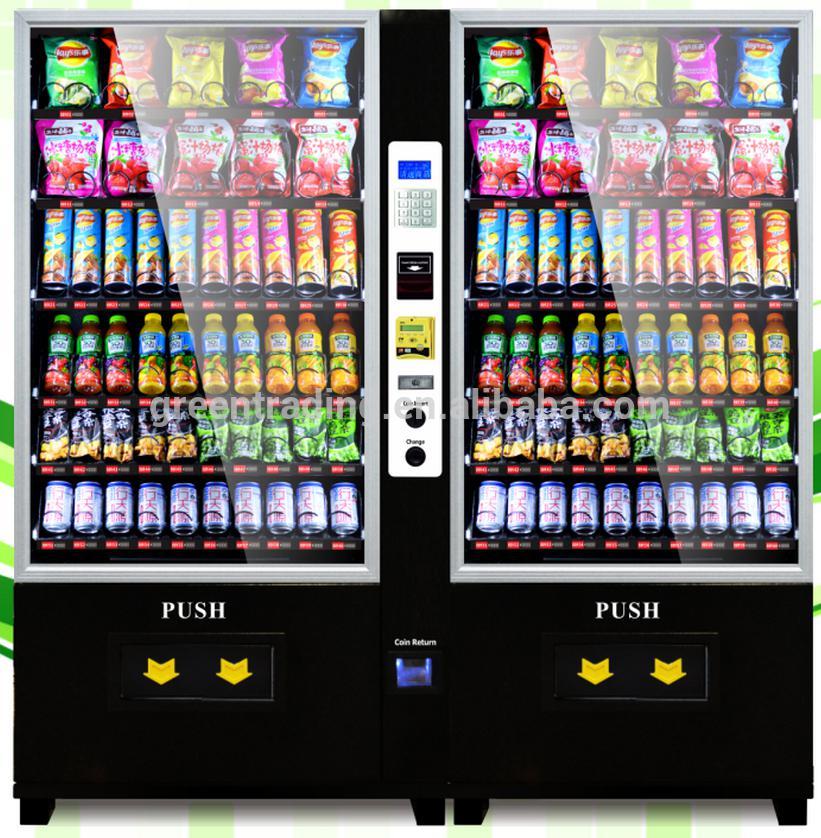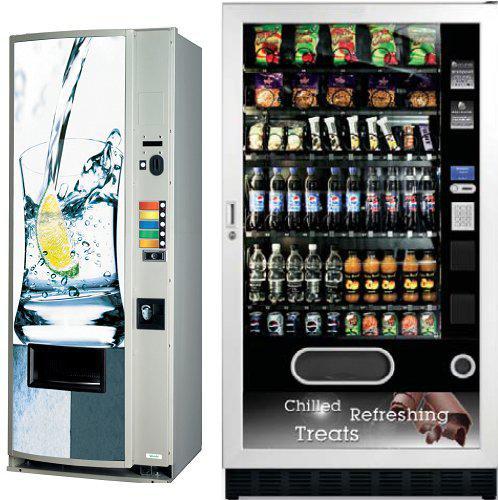The first image is the image on the left, the second image is the image on the right. For the images displayed, is the sentence "In one image, a vending machine unit has a central payment panel with equal sized vending machines on each side with six shelves each." factually correct? Answer yes or no. Yes. The first image is the image on the left, the second image is the image on the right. Considering the images on both sides, is "There are more machines in the image on the left than in the image on the right." valid? Answer yes or no. No. 